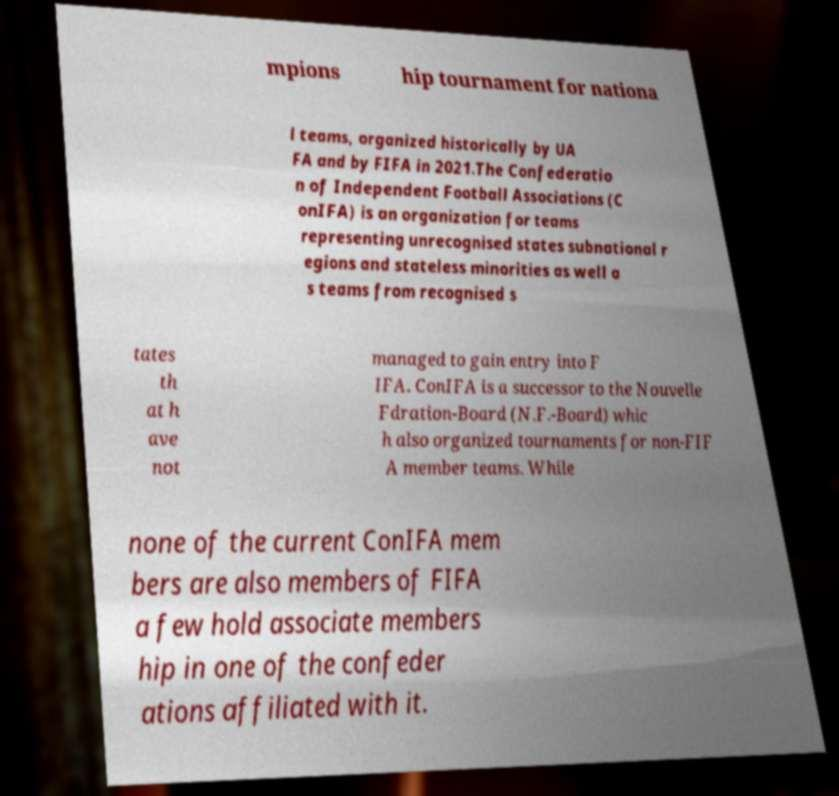For documentation purposes, I need the text within this image transcribed. Could you provide that? mpions hip tournament for nationa l teams, organized historically by UA FA and by FIFA in 2021.The Confederatio n of Independent Football Associations (C onIFA) is an organization for teams representing unrecognised states subnational r egions and stateless minorities as well a s teams from recognised s tates th at h ave not managed to gain entry into F IFA. ConIFA is a successor to the Nouvelle Fdration-Board (N.F.-Board) whic h also organized tournaments for non-FIF A member teams. While none of the current ConIFA mem bers are also members of FIFA a few hold associate members hip in one of the confeder ations affiliated with it. 